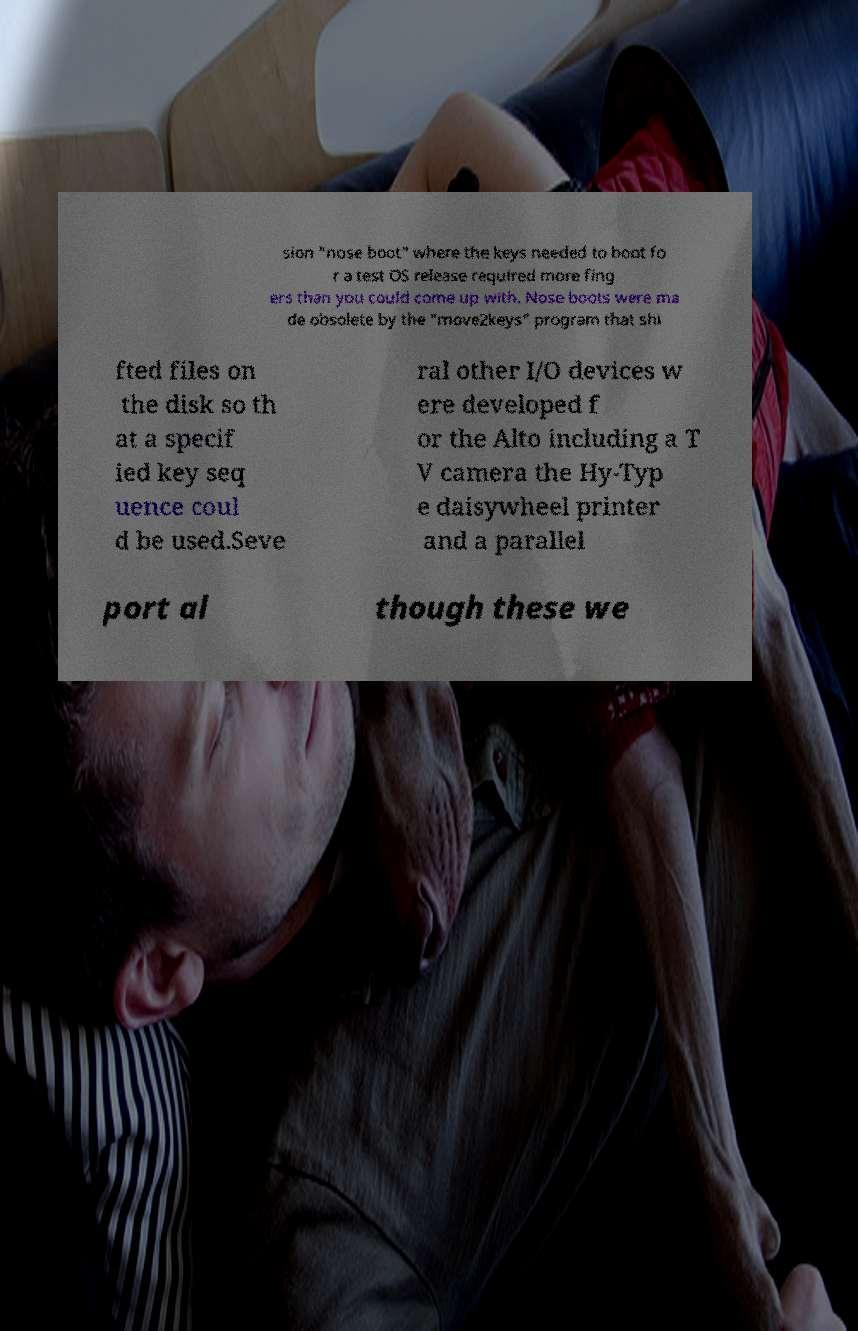Please identify and transcribe the text found in this image. sion "nose boot" where the keys needed to boot fo r a test OS release required more fing ers than you could come up with. Nose boots were ma de obsolete by the "move2keys" program that shi fted files on the disk so th at a specif ied key seq uence coul d be used.Seve ral other I/O devices w ere developed f or the Alto including a T V camera the Hy-Typ e daisywheel printer and a parallel port al though these we 